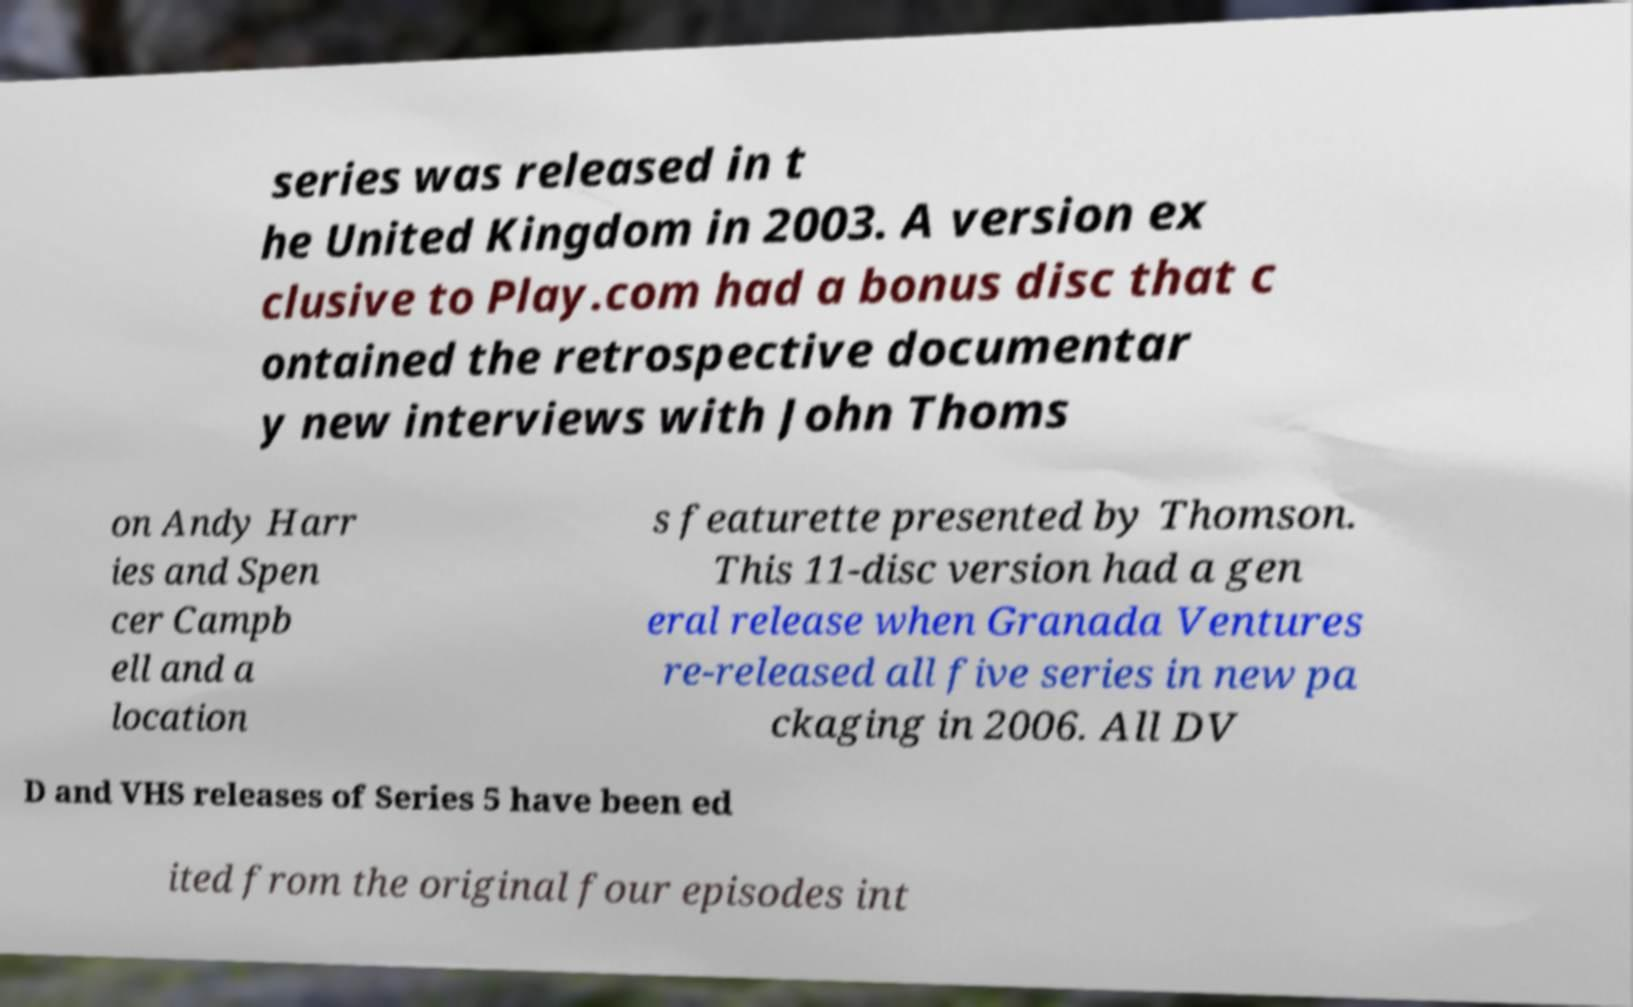Could you assist in decoding the text presented in this image and type it out clearly? series was released in t he United Kingdom in 2003. A version ex clusive to Play.com had a bonus disc that c ontained the retrospective documentar y new interviews with John Thoms on Andy Harr ies and Spen cer Campb ell and a location s featurette presented by Thomson. This 11-disc version had a gen eral release when Granada Ventures re-released all five series in new pa ckaging in 2006. All DV D and VHS releases of Series 5 have been ed ited from the original four episodes int 